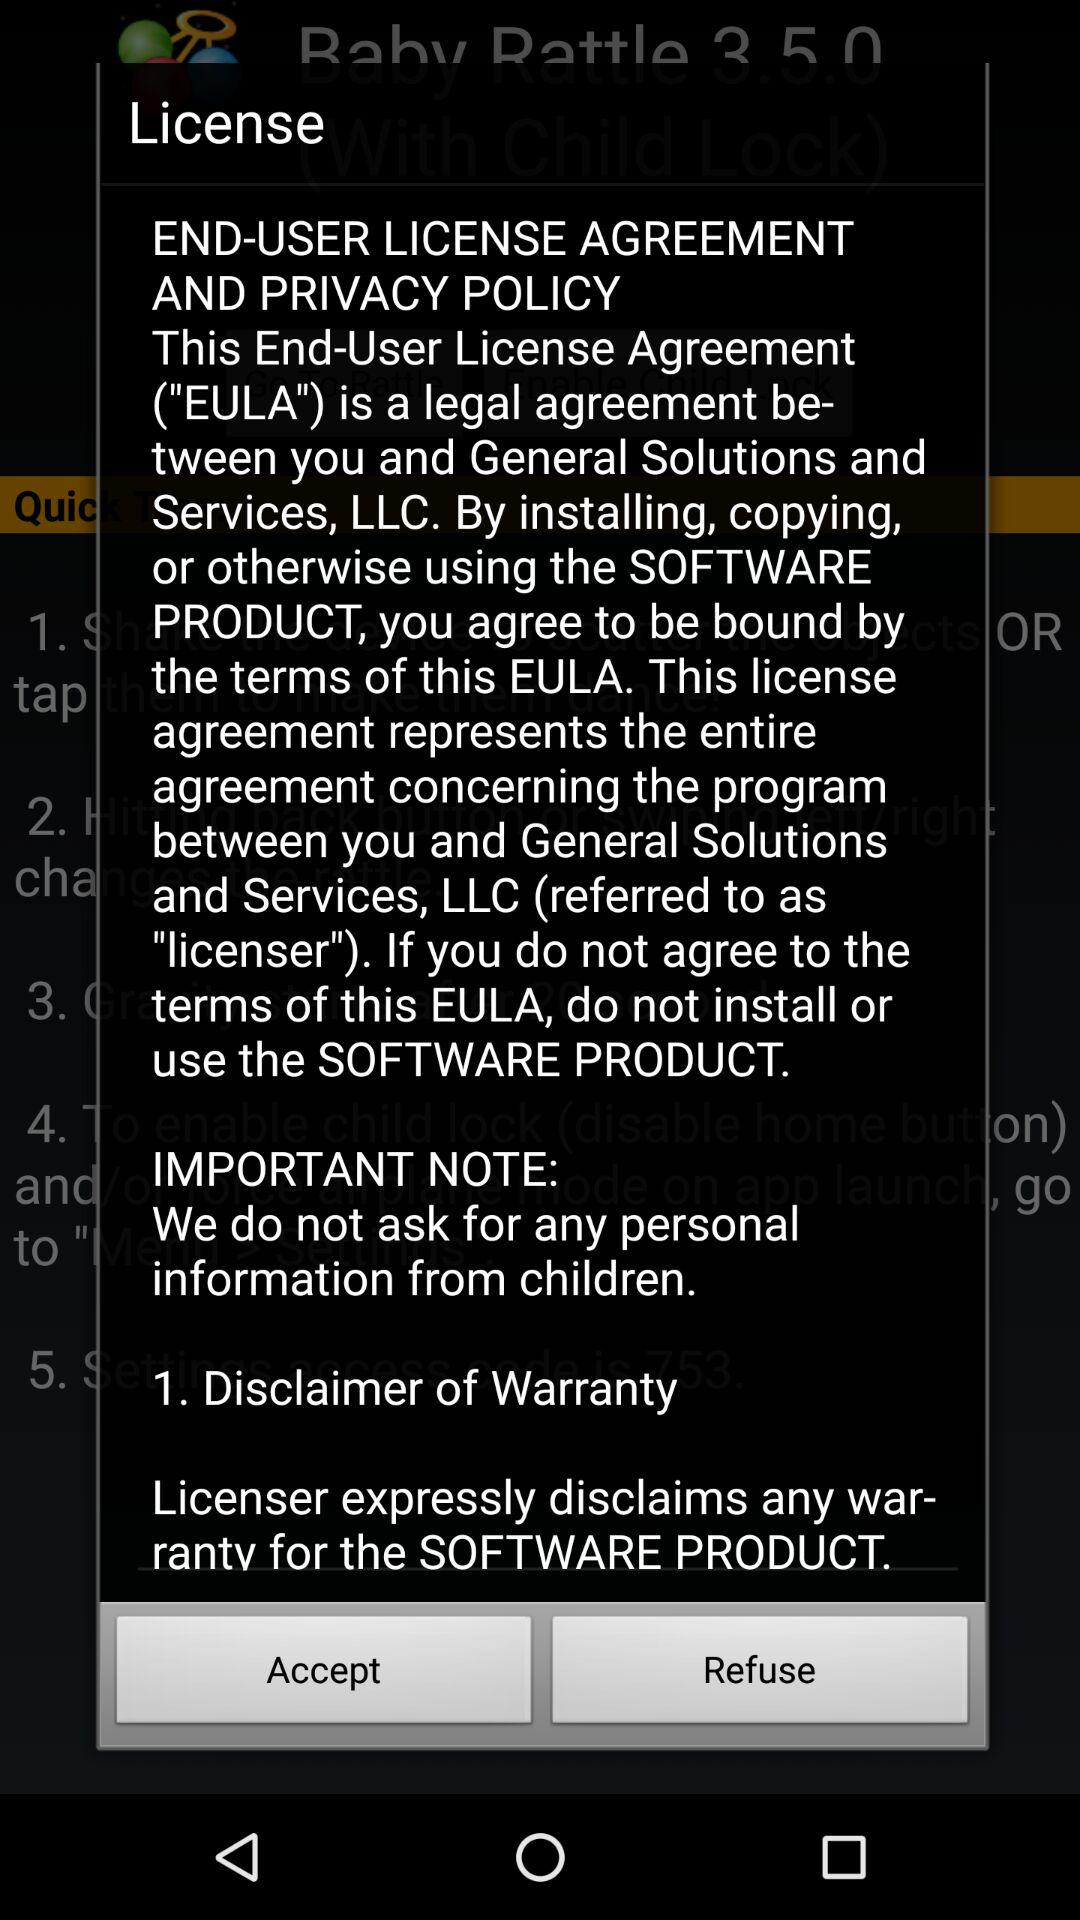What are the important notes? The important note is, "We do not ask for any personal information from children". 